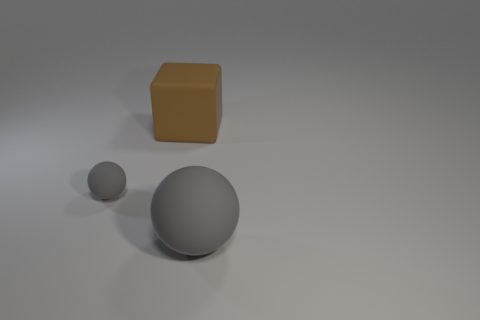There is a gray thing that is on the right side of the object that is on the left side of the block; are there any large brown cubes on the left side of it?
Offer a terse response. Yes. The matte block is what color?
Offer a terse response. Brown. The matte ball that is the same size as the brown thing is what color?
Offer a very short reply. Gray. There is a gray matte object to the right of the large brown thing; is it the same shape as the small matte object?
Your response must be concise. Yes. The sphere in front of the sphere to the left of the gray rubber thing that is right of the rubber block is what color?
Ensure brevity in your answer.  Gray. Are there any big red rubber cylinders?
Offer a terse response. No. What number of other things are the same size as the matte cube?
Your answer should be compact. 1. There is a big sphere; is it the same color as the ball that is behind the large gray thing?
Give a very brief answer. Yes. How many objects are either cubes or gray things?
Give a very brief answer. 3. Is there any other thing of the same color as the big sphere?
Ensure brevity in your answer.  Yes. 